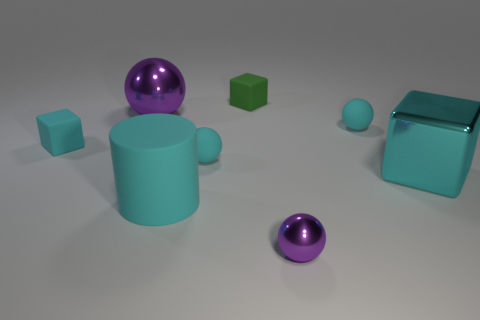What could be the use of these objects if they were real? If these objects were real, the cylinder might be a storage container, the spheres could serve as decorative orbs or balls used in games, and the cubes might function as building blocks or weights. 